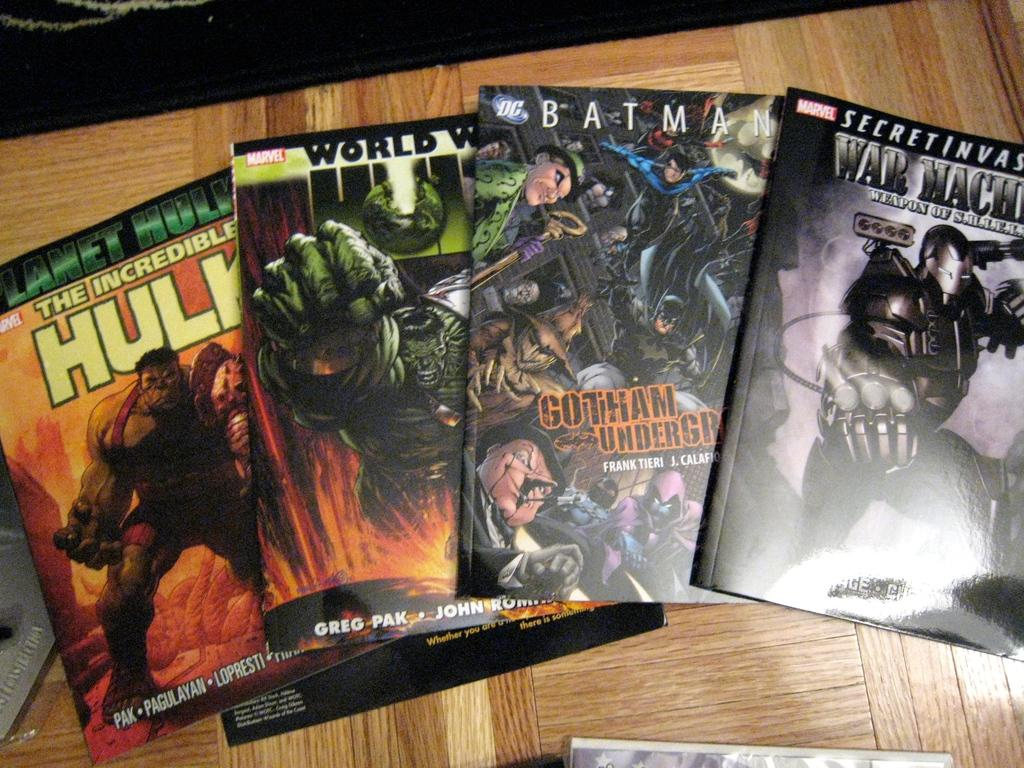<image>
Summarize the visual content of the image. The comic book is entitled "The Incredible Hulk" and has a picture of the hulk on the cover. 